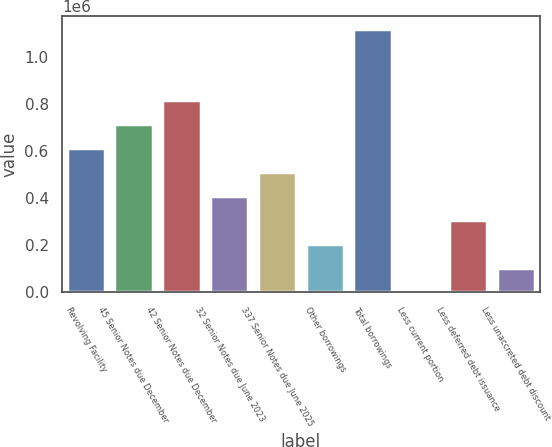<chart> <loc_0><loc_0><loc_500><loc_500><bar_chart><fcel>Revolving Facility<fcel>45 Senior Notes due December<fcel>42 Senior Notes due December<fcel>32 Senior Notes due June 2023<fcel>337 Senior Notes due June 2025<fcel>Other borrowings<fcel>Total borrowings<fcel>Less current portion<fcel>Less deferred debt issuance<fcel>Less unaccreted debt discount<nl><fcel>612942<fcel>714925<fcel>816908<fcel>408977<fcel>510960<fcel>205011<fcel>1.11622e+06<fcel>1046<fcel>306994<fcel>103029<nl></chart> 